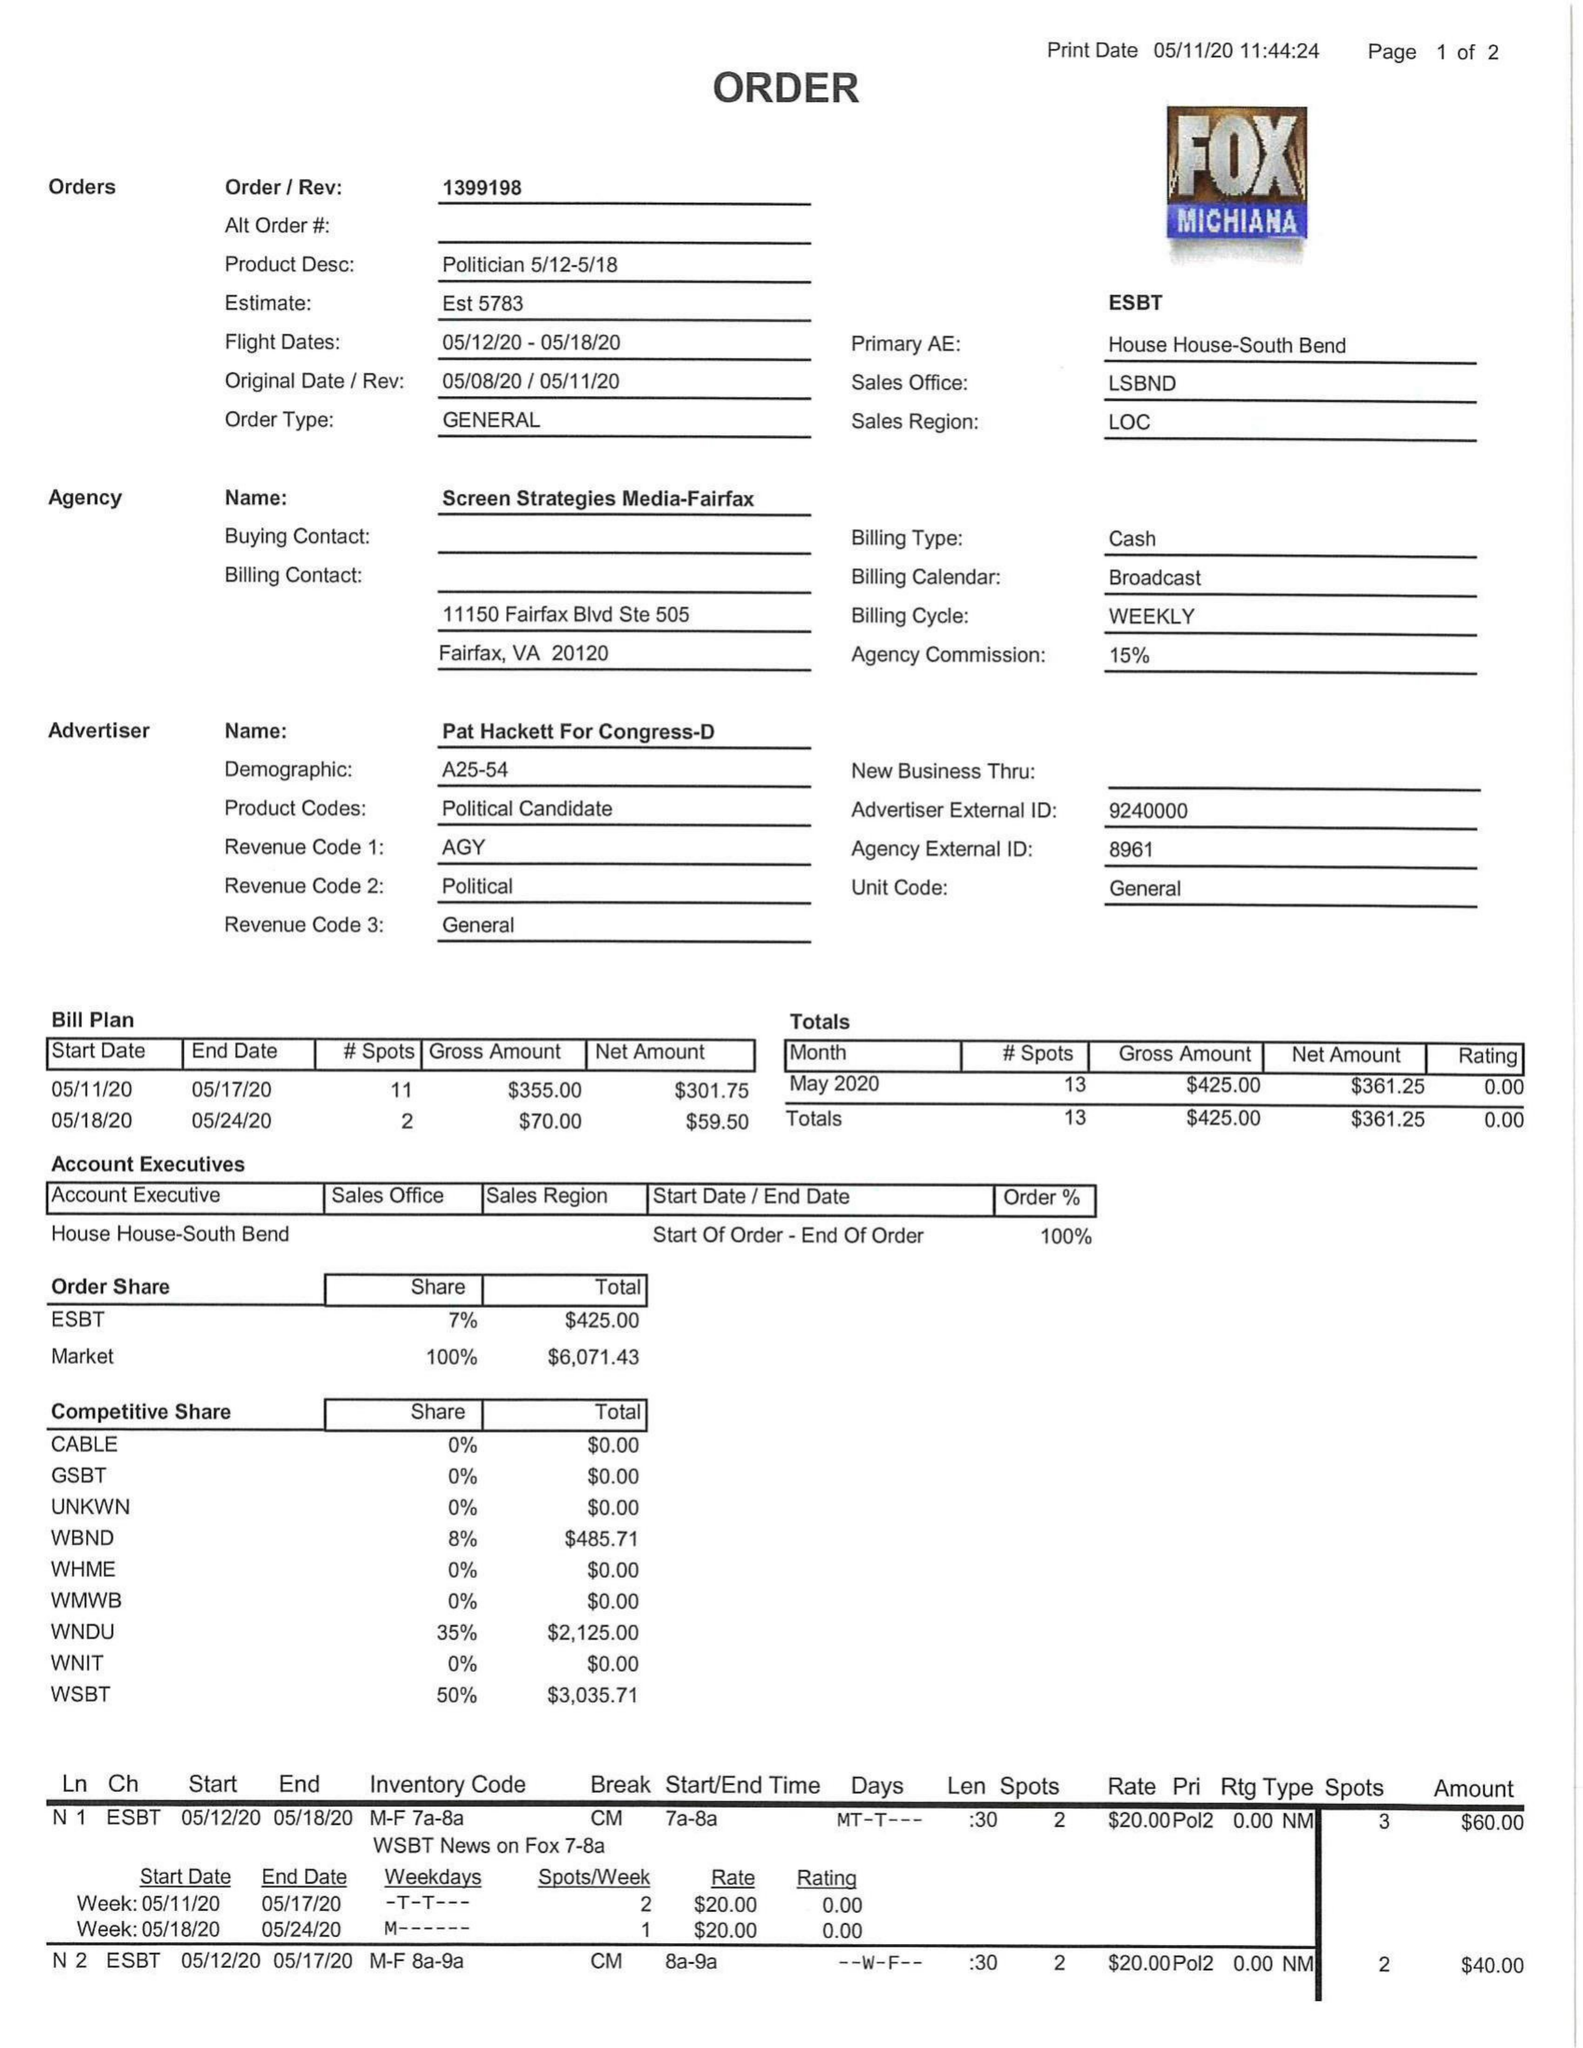What is the value for the contract_num?
Answer the question using a single word or phrase. 1399198 